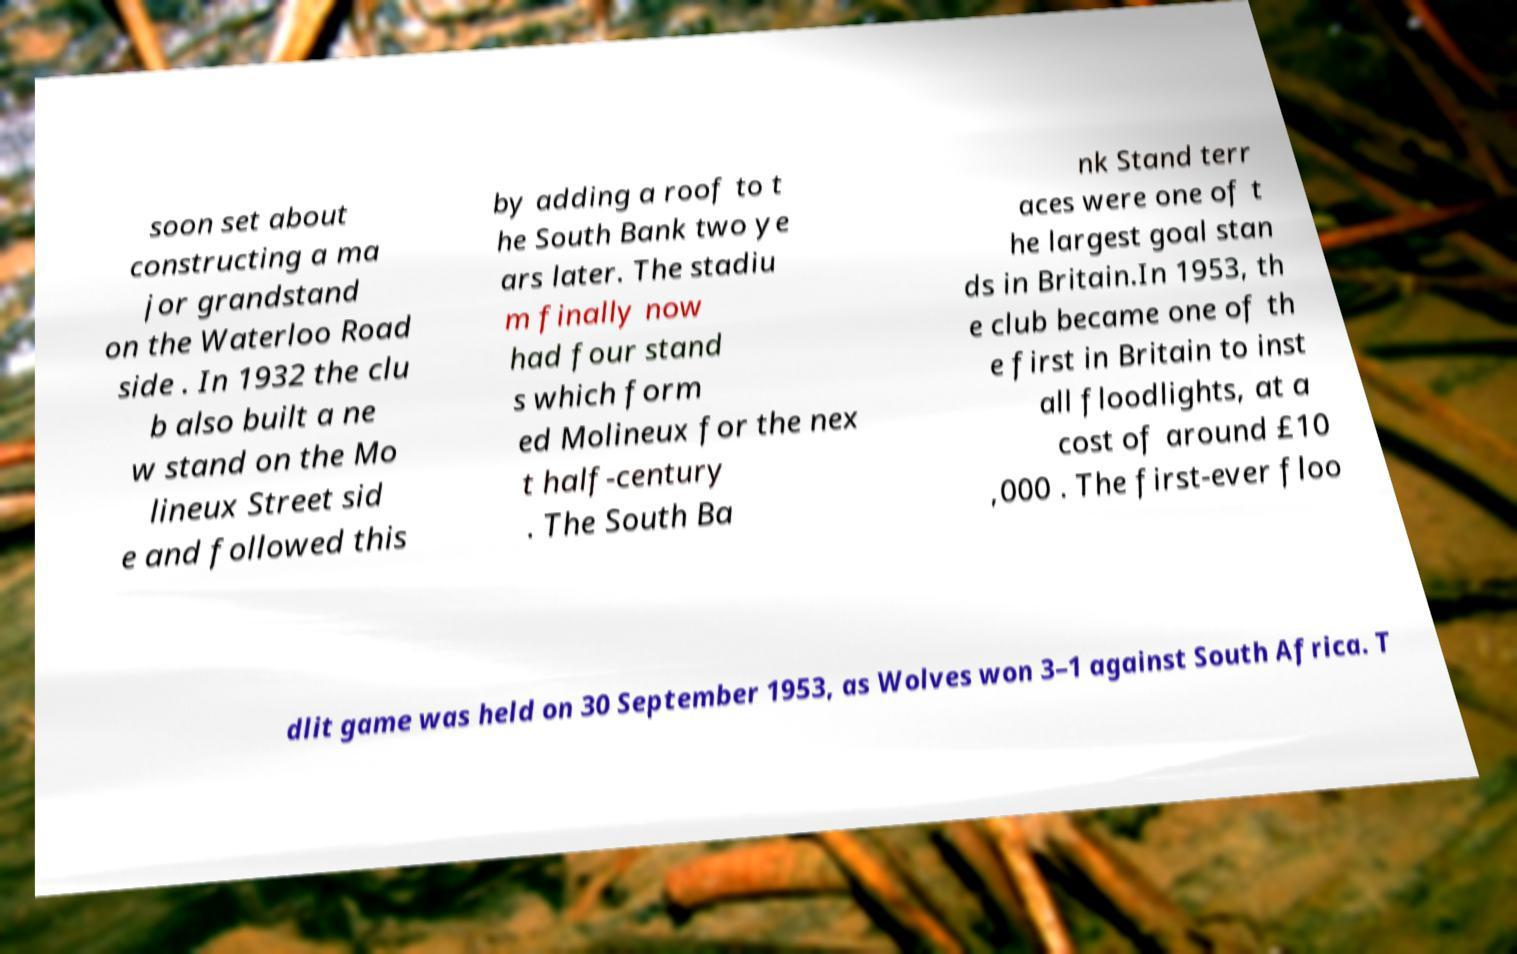Can you accurately transcribe the text from the provided image for me? soon set about constructing a ma jor grandstand on the Waterloo Road side . In 1932 the clu b also built a ne w stand on the Mo lineux Street sid e and followed this by adding a roof to t he South Bank two ye ars later. The stadiu m finally now had four stand s which form ed Molineux for the nex t half-century . The South Ba nk Stand terr aces were one of t he largest goal stan ds in Britain.In 1953, th e club became one of th e first in Britain to inst all floodlights, at a cost of around £10 ,000 . The first-ever floo dlit game was held on 30 September 1953, as Wolves won 3–1 against South Africa. T 